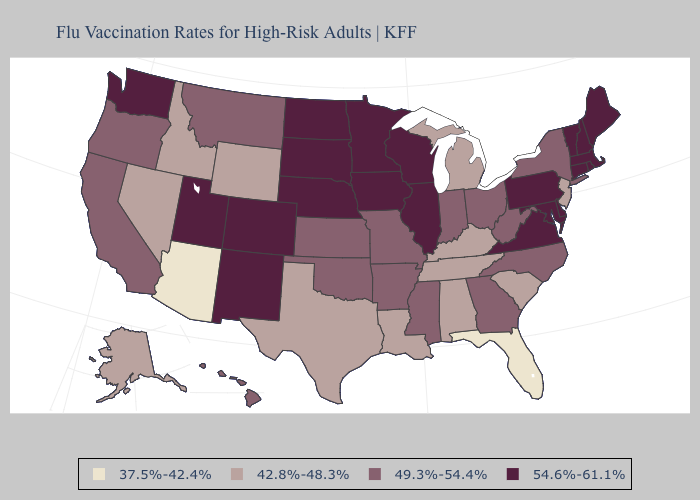Name the states that have a value in the range 42.8%-48.3%?
Give a very brief answer. Alabama, Alaska, Idaho, Kentucky, Louisiana, Michigan, Nevada, New Jersey, South Carolina, Tennessee, Texas, Wyoming. Among the states that border Colorado , does Utah have the highest value?
Write a very short answer. Yes. Among the states that border Kentucky , which have the highest value?
Keep it brief. Illinois, Virginia. Name the states that have a value in the range 54.6%-61.1%?
Give a very brief answer. Colorado, Connecticut, Delaware, Illinois, Iowa, Maine, Maryland, Massachusetts, Minnesota, Nebraska, New Hampshire, New Mexico, North Dakota, Pennsylvania, Rhode Island, South Dakota, Utah, Vermont, Virginia, Washington, Wisconsin. Among the states that border Kansas , which have the highest value?
Answer briefly. Colorado, Nebraska. Does Virginia have the lowest value in the USA?
Keep it brief. No. Does Washington have the highest value in the USA?
Give a very brief answer. Yes. Does Arkansas have a higher value than West Virginia?
Answer briefly. No. What is the highest value in the South ?
Answer briefly. 54.6%-61.1%. Does Indiana have the same value as Hawaii?
Keep it brief. Yes. What is the value of West Virginia?
Concise answer only. 49.3%-54.4%. What is the highest value in states that border New Jersey?
Answer briefly. 54.6%-61.1%. What is the lowest value in states that border North Dakota?
Be succinct. 49.3%-54.4%. Name the states that have a value in the range 37.5%-42.4%?
Write a very short answer. Arizona, Florida. Does Connecticut have the highest value in the Northeast?
Answer briefly. Yes. 